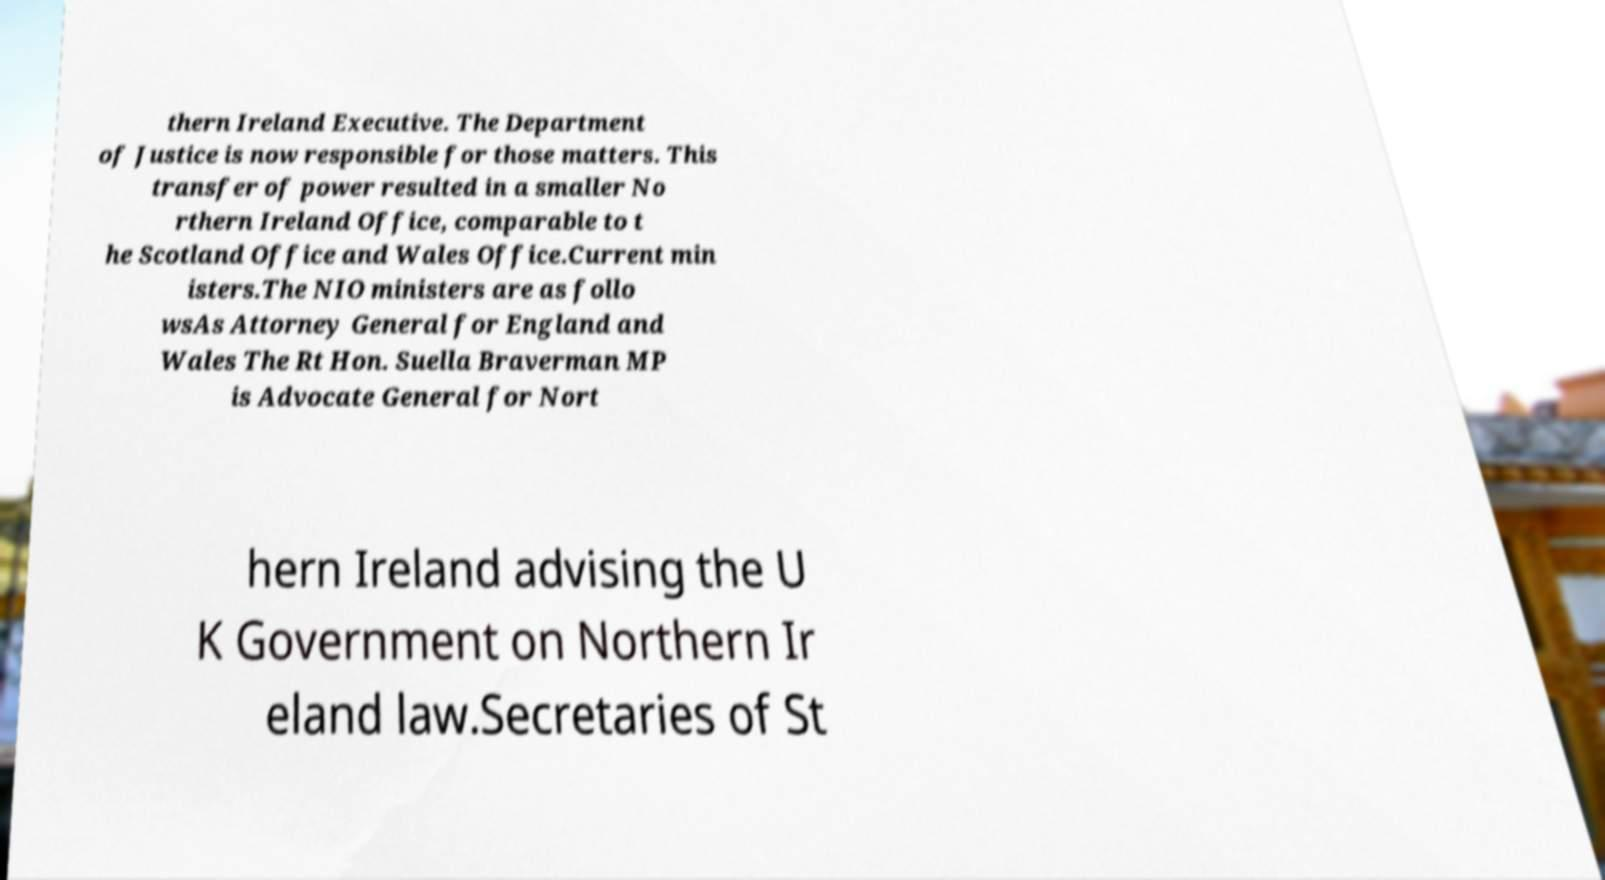Could you extract and type out the text from this image? thern Ireland Executive. The Department of Justice is now responsible for those matters. This transfer of power resulted in a smaller No rthern Ireland Office, comparable to t he Scotland Office and Wales Office.Current min isters.The NIO ministers are as follo wsAs Attorney General for England and Wales The Rt Hon. Suella Braverman MP is Advocate General for Nort hern Ireland advising the U K Government on Northern Ir eland law.Secretaries of St 